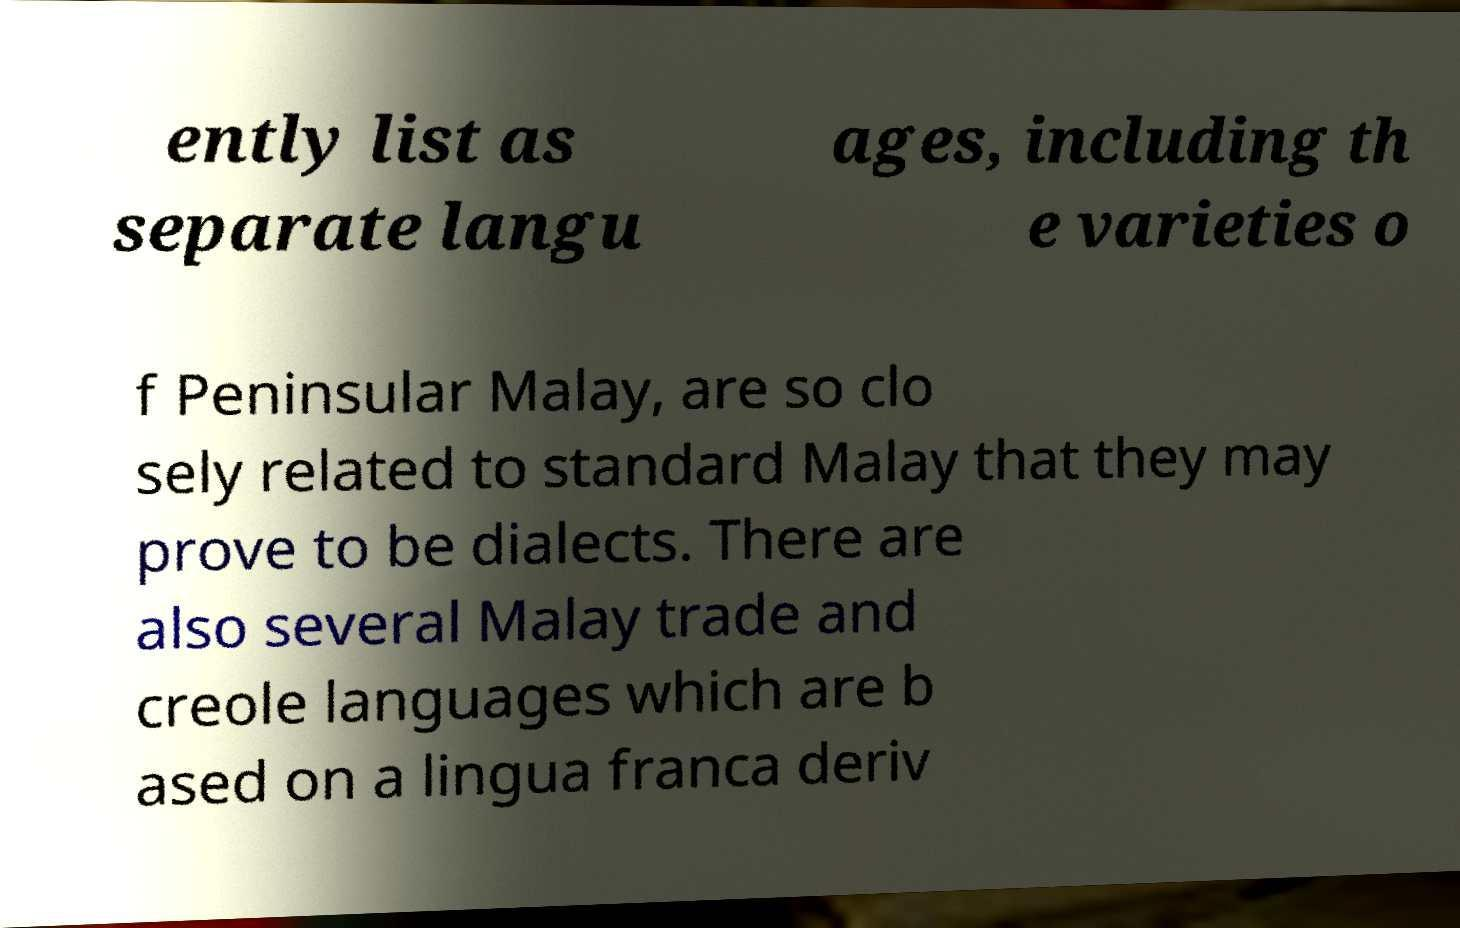Could you extract and type out the text from this image? ently list as separate langu ages, including th e varieties o f Peninsular Malay, are so clo sely related to standard Malay that they may prove to be dialects. There are also several Malay trade and creole languages which are b ased on a lingua franca deriv 